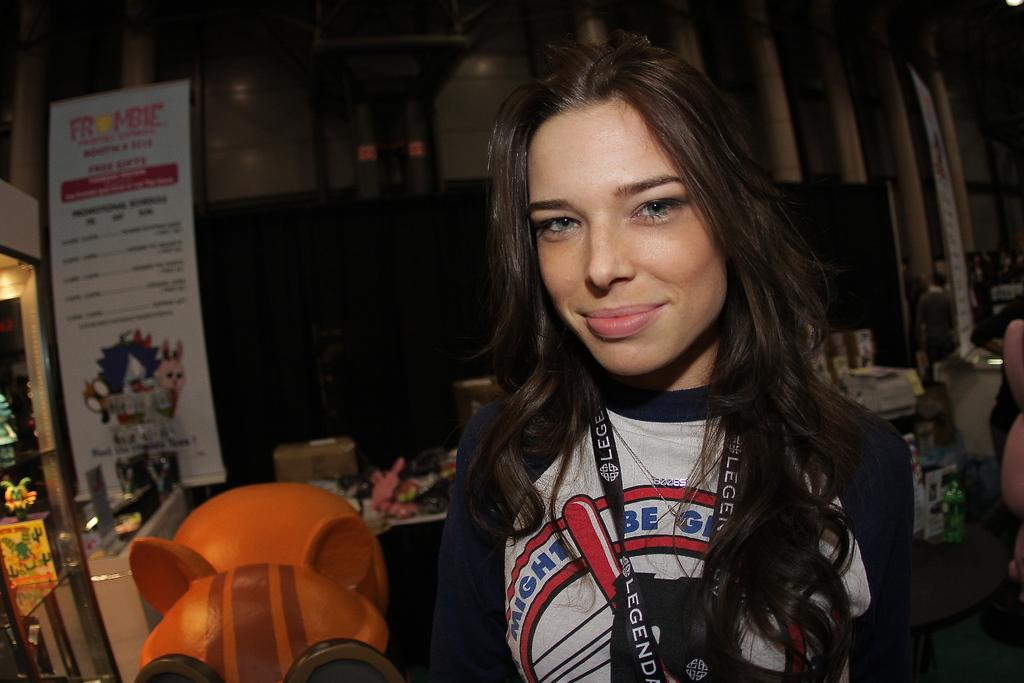<image>
Create a compact narrative representing the image presented. A woman whose shirt slogan starts with "might be" is wearing a black lanyard around her neck. 